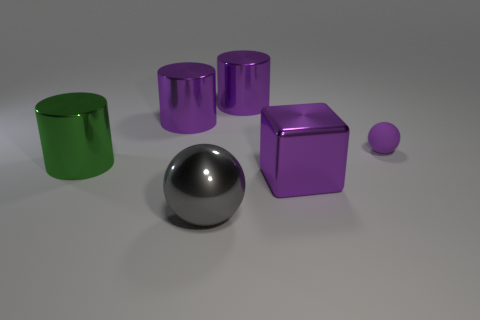How many large things are the same shape as the tiny thing?
Provide a succinct answer. 1. Do the large object that is in front of the purple block and the cube have the same color?
Your answer should be very brief. No. What is the shape of the large thing that is to the left of the large purple cylinder that is left of the object in front of the big block?
Give a very brief answer. Cylinder. Is the size of the purple rubber sphere the same as the purple cylinder left of the gray shiny thing?
Offer a terse response. No. Is there a gray metal ball that has the same size as the matte sphere?
Give a very brief answer. No. How many other things are there of the same material as the small purple sphere?
Provide a short and direct response. 0. The big object that is right of the big gray object and in front of the green metal cylinder is what color?
Make the answer very short. Purple. Do the sphere that is in front of the green metallic cylinder and the large purple thing in front of the purple rubber sphere have the same material?
Offer a terse response. Yes. There is a sphere that is in front of the purple shiny cube; is its size the same as the purple block?
Give a very brief answer. Yes. Is the color of the big block the same as the sphere that is to the left of the tiny thing?
Keep it short and to the point. No. 